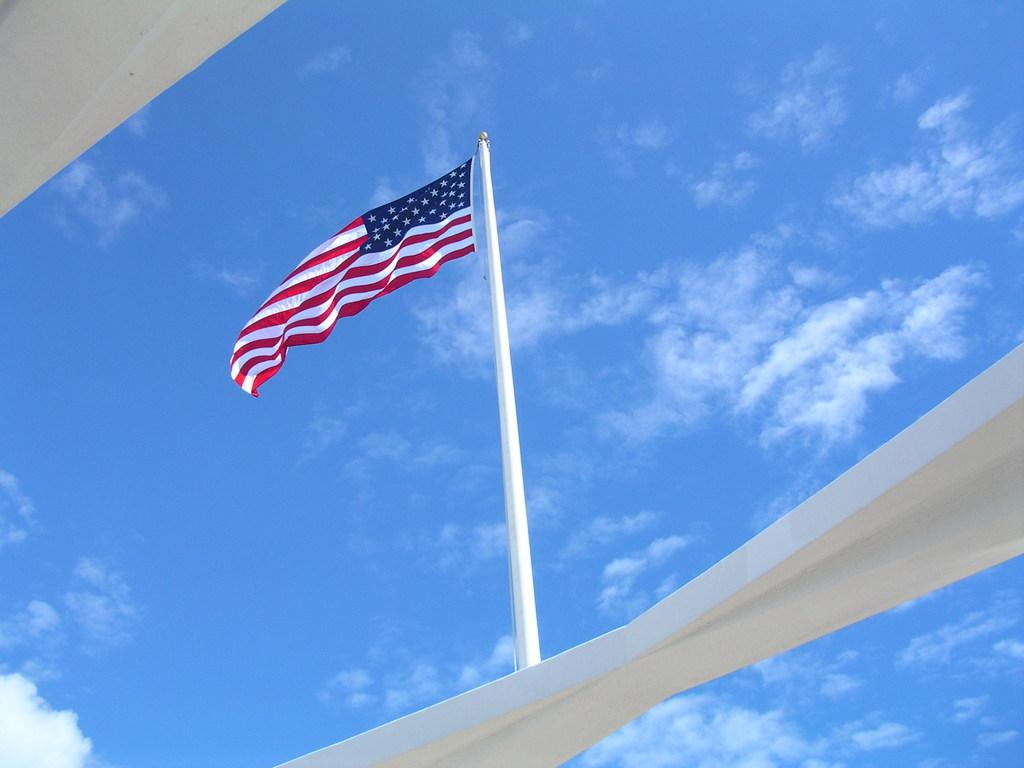Where was the picture taken? The picture was clicked outside. What is the main subject of the image? There is a flag in the center of the image. How is the flag positioned in the image? The flag is attached to a pole. What color can be seen in the image? There are white color objects in the image. What can be seen in the background of the image? The sky is visible in the background of the image. What is the weather like in the image? The presence of clouds in the sky suggests that it might be partly cloudy. What is the reaction of the town to the development in the image? There is no town or development present in the image; it features a flag attached to a pole with a background of the sky and clouds. 